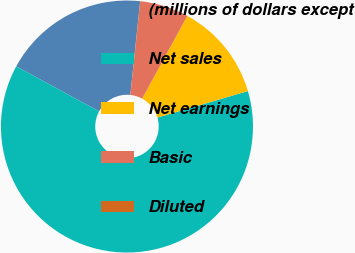Convert chart to OTSL. <chart><loc_0><loc_0><loc_500><loc_500><pie_chart><fcel>(millions of dollars except<fcel>Net sales<fcel>Net earnings<fcel>Basic<fcel>Diluted<nl><fcel>18.75%<fcel>62.46%<fcel>12.51%<fcel>6.26%<fcel>0.02%<nl></chart> 